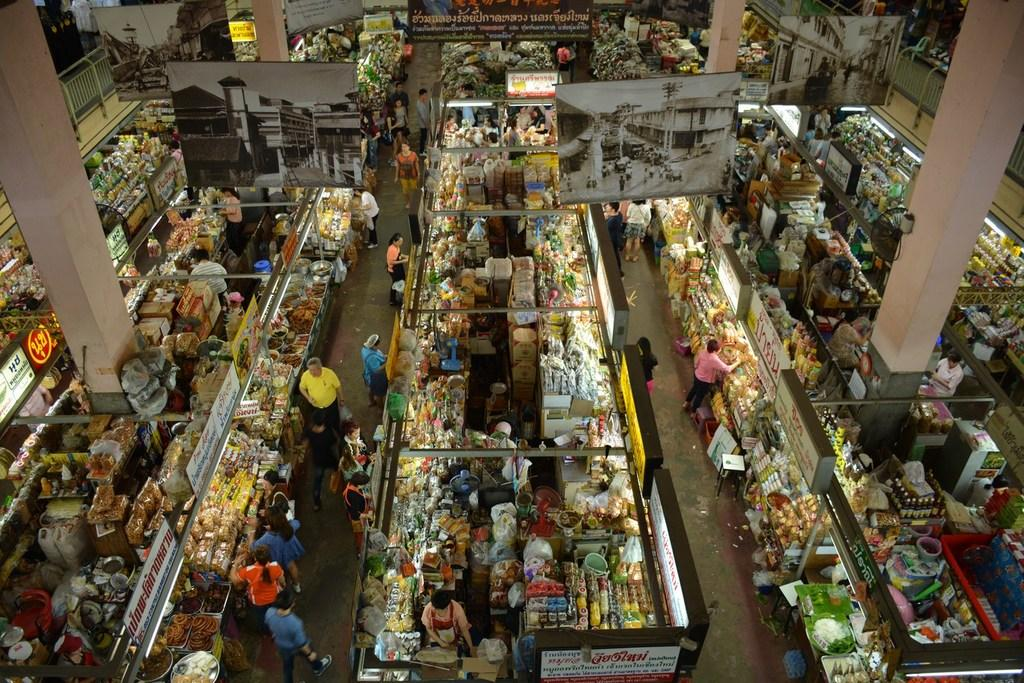<image>
Describe the image concisely. Overhead view of a market containing banners and aisle markers in a foreign language. 